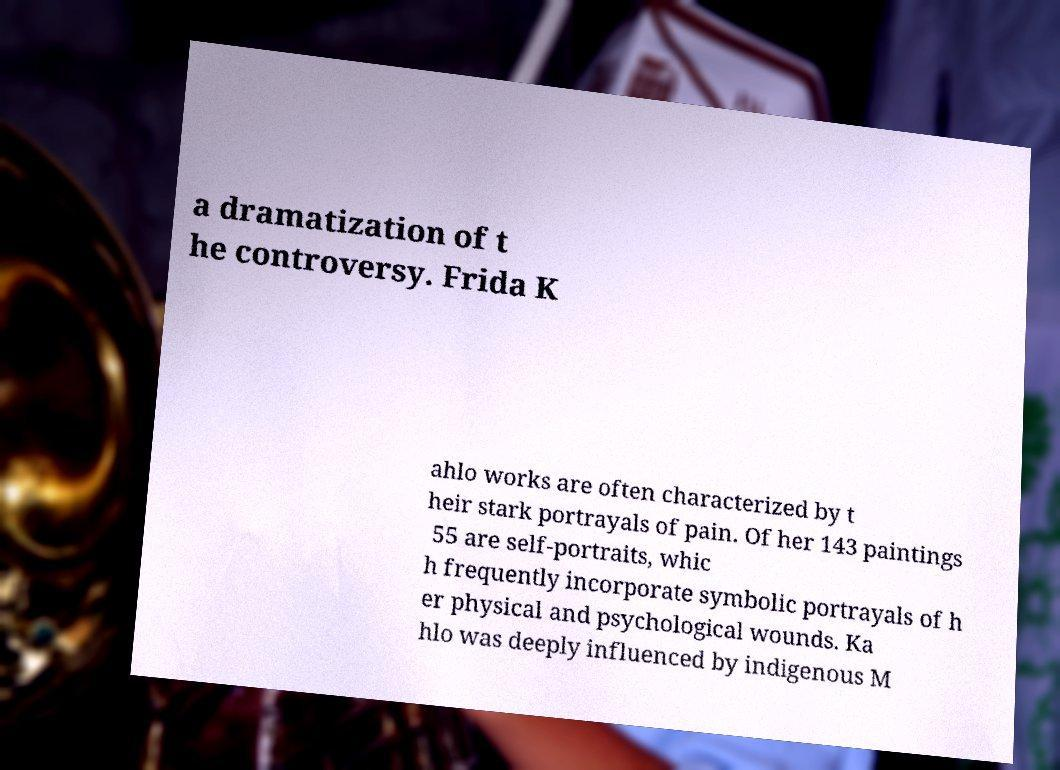There's text embedded in this image that I need extracted. Can you transcribe it verbatim? a dramatization of t he controversy. Frida K ahlo works are often characterized by t heir stark portrayals of pain. Of her 143 paintings 55 are self-portraits, whic h frequently incorporate symbolic portrayals of h er physical and psychological wounds. Ka hlo was deeply influenced by indigenous M 